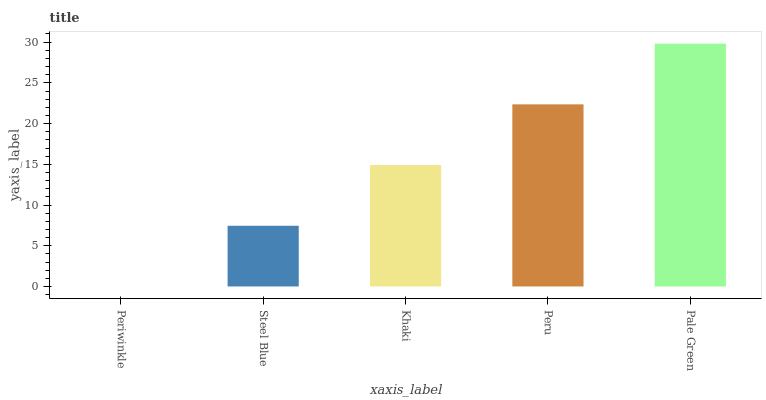Is Steel Blue the minimum?
Answer yes or no. No. Is Steel Blue the maximum?
Answer yes or no. No. Is Steel Blue greater than Periwinkle?
Answer yes or no. Yes. Is Periwinkle less than Steel Blue?
Answer yes or no. Yes. Is Periwinkle greater than Steel Blue?
Answer yes or no. No. Is Steel Blue less than Periwinkle?
Answer yes or no. No. Is Khaki the high median?
Answer yes or no. Yes. Is Khaki the low median?
Answer yes or no. Yes. Is Peru the high median?
Answer yes or no. No. Is Steel Blue the low median?
Answer yes or no. No. 